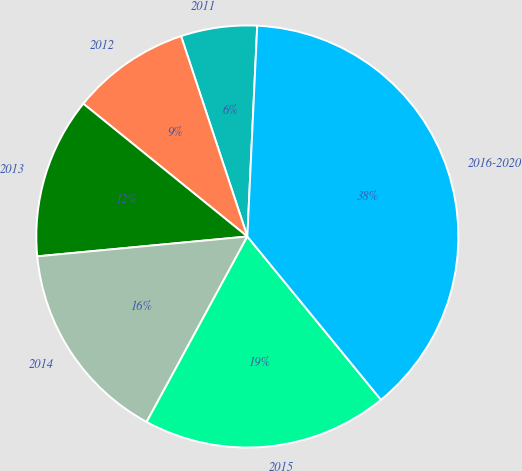Convert chart to OTSL. <chart><loc_0><loc_0><loc_500><loc_500><pie_chart><fcel>2011<fcel>2012<fcel>2013<fcel>2014<fcel>2015<fcel>2016-2020<nl><fcel>5.83%<fcel>9.08%<fcel>12.33%<fcel>15.58%<fcel>18.83%<fcel>38.33%<nl></chart> 